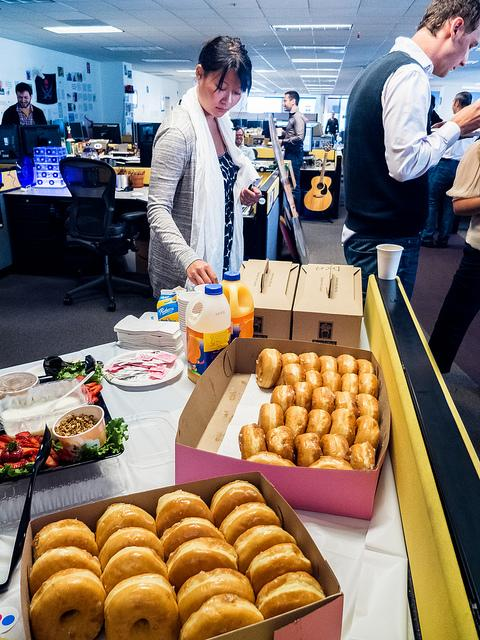What setting does this seem to be? Please explain your reasoning. office. There are cubicles and computer work stations in the background. 